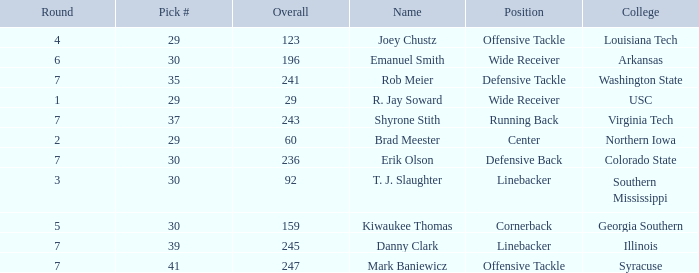What is the average Round for wide receiver r. jay soward and Overall smaller than 29? None. 